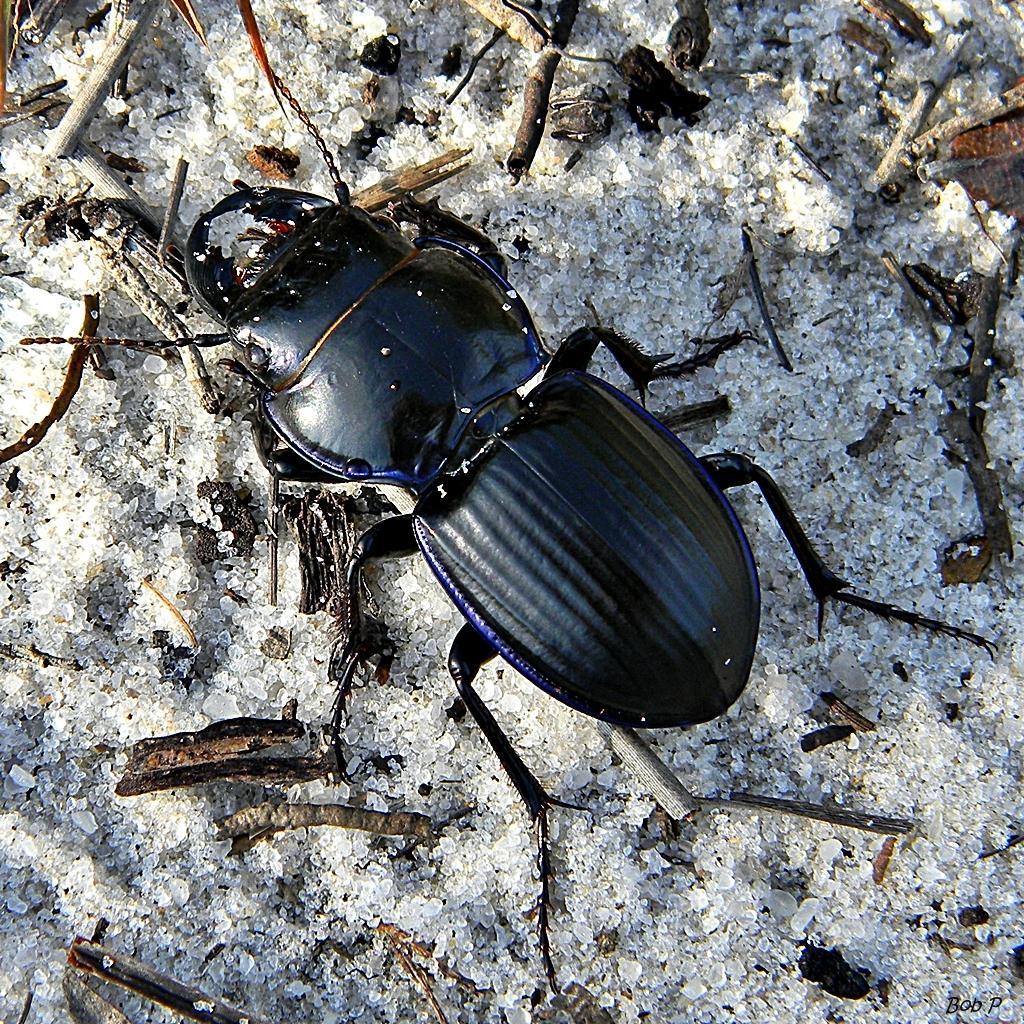Could you give a brief overview of what you see in this image? In this picture we can see an insect and aside to this insect we can see wooden sticks. 